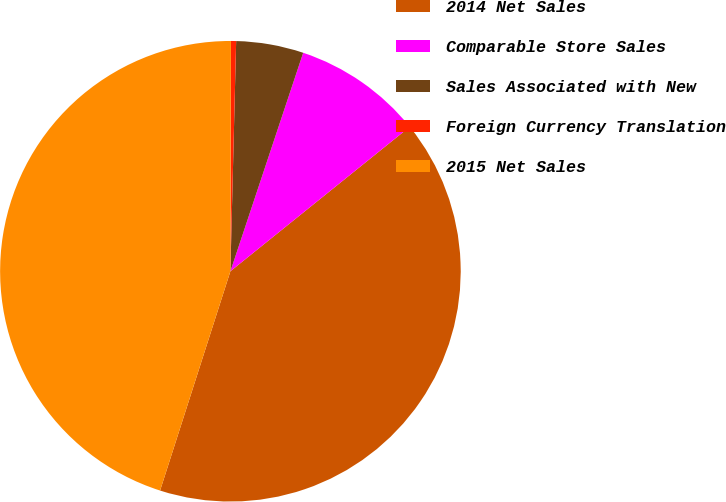Convert chart to OTSL. <chart><loc_0><loc_0><loc_500><loc_500><pie_chart><fcel>2014 Net Sales<fcel>Comparable Store Sales<fcel>Sales Associated with New<fcel>Foreign Currency Translation<fcel>2015 Net Sales<nl><fcel>40.73%<fcel>9.09%<fcel>4.72%<fcel>0.36%<fcel>45.1%<nl></chart> 